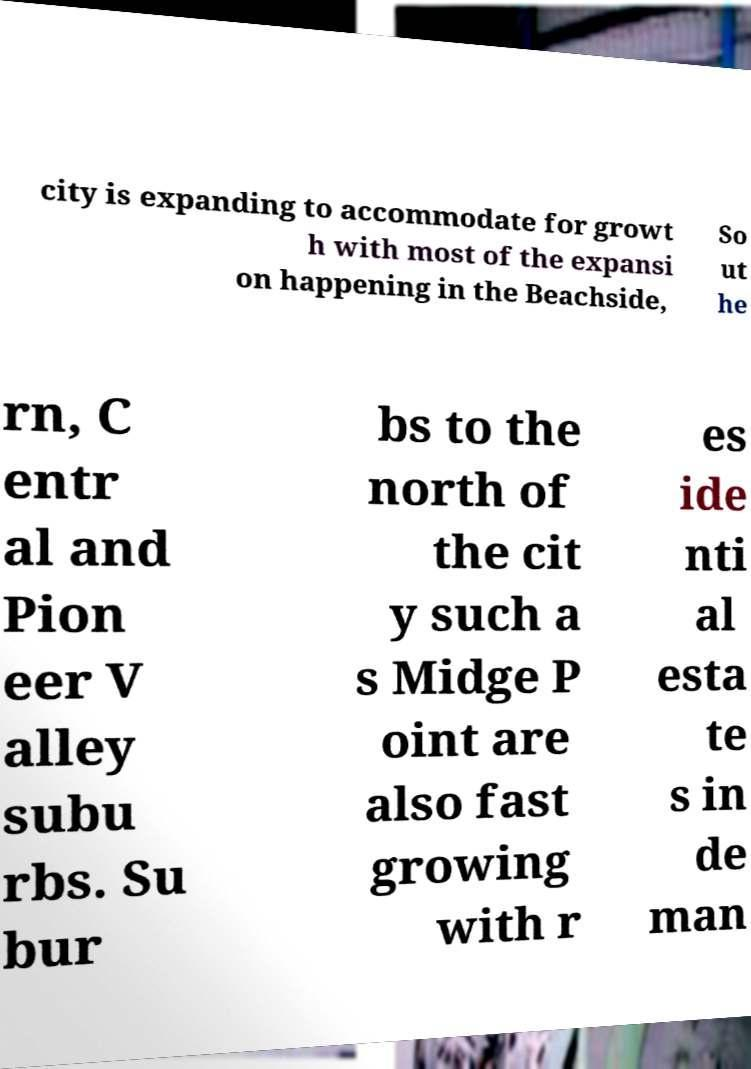Could you extract and type out the text from this image? city is expanding to accommodate for growt h with most of the expansi on happening in the Beachside, So ut he rn, C entr al and Pion eer V alley subu rbs. Su bur bs to the north of the cit y such a s Midge P oint are also fast growing with r es ide nti al esta te s in de man 